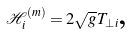<formula> <loc_0><loc_0><loc_500><loc_500>\mathcal { H } _ { i } ^ { ( m ) } = 2 \sqrt { g } T _ { \bot i } \text {,}</formula> 